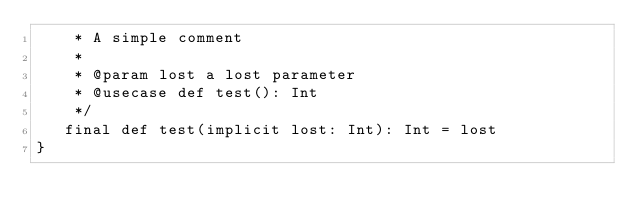<code> <loc_0><loc_0><loc_500><loc_500><_Scala_>    * A simple comment
    * 
    * @param lost a lost parameter
    * @usecase def test(): Int
    */
   final def test(implicit lost: Int): Int = lost
}
</code> 